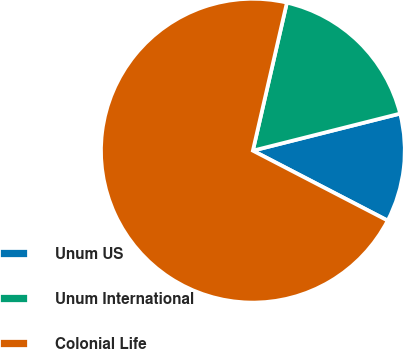Convert chart. <chart><loc_0><loc_0><loc_500><loc_500><pie_chart><fcel>Unum US<fcel>Unum International<fcel>Colonial Life<nl><fcel>11.54%<fcel>17.48%<fcel>70.98%<nl></chart> 